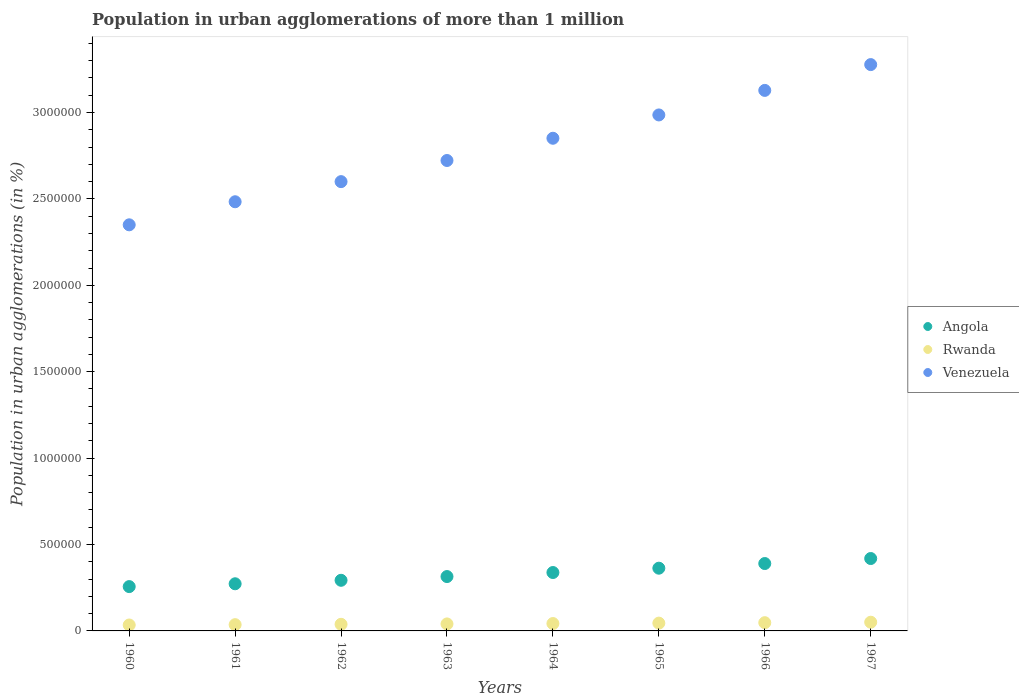What is the population in urban agglomerations in Rwanda in 1965?
Provide a short and direct response. 4.51e+04. Across all years, what is the maximum population in urban agglomerations in Venezuela?
Offer a terse response. 3.28e+06. Across all years, what is the minimum population in urban agglomerations in Angola?
Make the answer very short. 2.56e+05. In which year was the population in urban agglomerations in Rwanda maximum?
Your answer should be compact. 1967. In which year was the population in urban agglomerations in Angola minimum?
Your answer should be very brief. 1960. What is the total population in urban agglomerations in Venezuela in the graph?
Keep it short and to the point. 2.24e+07. What is the difference between the population in urban agglomerations in Angola in 1962 and that in 1964?
Your answer should be very brief. -4.50e+04. What is the difference between the population in urban agglomerations in Angola in 1967 and the population in urban agglomerations in Rwanda in 1964?
Your answer should be compact. 3.76e+05. What is the average population in urban agglomerations in Angola per year?
Provide a short and direct response. 3.31e+05. In the year 1966, what is the difference between the population in urban agglomerations in Angola and population in urban agglomerations in Venezuela?
Your answer should be compact. -2.74e+06. What is the ratio of the population in urban agglomerations in Angola in 1964 to that in 1965?
Ensure brevity in your answer.  0.93. What is the difference between the highest and the second highest population in urban agglomerations in Venezuela?
Give a very brief answer. 1.49e+05. What is the difference between the highest and the lowest population in urban agglomerations in Rwanda?
Offer a terse response. 1.61e+04. Is it the case that in every year, the sum of the population in urban agglomerations in Angola and population in urban agglomerations in Rwanda  is greater than the population in urban agglomerations in Venezuela?
Keep it short and to the point. No. Does the population in urban agglomerations in Rwanda monotonically increase over the years?
Provide a succinct answer. Yes. How many years are there in the graph?
Give a very brief answer. 8. Are the values on the major ticks of Y-axis written in scientific E-notation?
Keep it short and to the point. No. Does the graph contain grids?
Offer a terse response. No. How are the legend labels stacked?
Keep it short and to the point. Vertical. What is the title of the graph?
Offer a very short reply. Population in urban agglomerations of more than 1 million. Does "Fragile and conflict affected situations" appear as one of the legend labels in the graph?
Provide a short and direct response. No. What is the label or title of the Y-axis?
Your answer should be very brief. Population in urban agglomerations (in %). What is the Population in urban agglomerations (in %) in Angola in 1960?
Give a very brief answer. 2.56e+05. What is the Population in urban agglomerations (in %) of Rwanda in 1960?
Make the answer very short. 3.43e+04. What is the Population in urban agglomerations (in %) in Venezuela in 1960?
Ensure brevity in your answer.  2.35e+06. What is the Population in urban agglomerations (in %) in Angola in 1961?
Your response must be concise. 2.73e+05. What is the Population in urban agglomerations (in %) in Rwanda in 1961?
Your answer should be compact. 3.63e+04. What is the Population in urban agglomerations (in %) in Venezuela in 1961?
Your answer should be very brief. 2.48e+06. What is the Population in urban agglomerations (in %) in Angola in 1962?
Make the answer very short. 2.93e+05. What is the Population in urban agglomerations (in %) of Rwanda in 1962?
Keep it short and to the point. 3.83e+04. What is the Population in urban agglomerations (in %) of Venezuela in 1962?
Ensure brevity in your answer.  2.60e+06. What is the Population in urban agglomerations (in %) of Angola in 1963?
Your response must be concise. 3.15e+05. What is the Population in urban agglomerations (in %) of Rwanda in 1963?
Give a very brief answer. 4.05e+04. What is the Population in urban agglomerations (in %) of Venezuela in 1963?
Offer a very short reply. 2.72e+06. What is the Population in urban agglomerations (in %) in Angola in 1964?
Give a very brief answer. 3.38e+05. What is the Population in urban agglomerations (in %) in Rwanda in 1964?
Provide a succinct answer. 4.27e+04. What is the Population in urban agglomerations (in %) of Venezuela in 1964?
Your answer should be compact. 2.85e+06. What is the Population in urban agglomerations (in %) of Angola in 1965?
Offer a very short reply. 3.63e+05. What is the Population in urban agglomerations (in %) in Rwanda in 1965?
Ensure brevity in your answer.  4.51e+04. What is the Population in urban agglomerations (in %) of Venezuela in 1965?
Keep it short and to the point. 2.99e+06. What is the Population in urban agglomerations (in %) in Angola in 1966?
Keep it short and to the point. 3.90e+05. What is the Population in urban agglomerations (in %) in Rwanda in 1966?
Ensure brevity in your answer.  4.77e+04. What is the Population in urban agglomerations (in %) of Venezuela in 1966?
Make the answer very short. 3.13e+06. What is the Population in urban agglomerations (in %) of Angola in 1967?
Your answer should be compact. 4.19e+05. What is the Population in urban agglomerations (in %) of Rwanda in 1967?
Offer a terse response. 5.04e+04. What is the Population in urban agglomerations (in %) in Venezuela in 1967?
Make the answer very short. 3.28e+06. Across all years, what is the maximum Population in urban agglomerations (in %) of Angola?
Provide a succinct answer. 4.19e+05. Across all years, what is the maximum Population in urban agglomerations (in %) in Rwanda?
Give a very brief answer. 5.04e+04. Across all years, what is the maximum Population in urban agglomerations (in %) of Venezuela?
Your answer should be very brief. 3.28e+06. Across all years, what is the minimum Population in urban agglomerations (in %) of Angola?
Your answer should be very brief. 2.56e+05. Across all years, what is the minimum Population in urban agglomerations (in %) in Rwanda?
Your answer should be very brief. 3.43e+04. Across all years, what is the minimum Population in urban agglomerations (in %) of Venezuela?
Your answer should be compact. 2.35e+06. What is the total Population in urban agglomerations (in %) of Angola in the graph?
Give a very brief answer. 2.65e+06. What is the total Population in urban agglomerations (in %) of Rwanda in the graph?
Give a very brief answer. 3.35e+05. What is the total Population in urban agglomerations (in %) of Venezuela in the graph?
Offer a terse response. 2.24e+07. What is the difference between the Population in urban agglomerations (in %) of Angola in 1960 and that in 1961?
Make the answer very short. -1.63e+04. What is the difference between the Population in urban agglomerations (in %) of Rwanda in 1960 and that in 1961?
Make the answer very short. -1932. What is the difference between the Population in urban agglomerations (in %) of Venezuela in 1960 and that in 1961?
Ensure brevity in your answer.  -1.33e+05. What is the difference between the Population in urban agglomerations (in %) of Angola in 1960 and that in 1962?
Your answer should be compact. -3.65e+04. What is the difference between the Population in urban agglomerations (in %) of Rwanda in 1960 and that in 1962?
Offer a very short reply. -3976. What is the difference between the Population in urban agglomerations (in %) of Venezuela in 1960 and that in 1962?
Give a very brief answer. -2.50e+05. What is the difference between the Population in urban agglomerations (in %) of Angola in 1960 and that in 1963?
Offer a terse response. -5.81e+04. What is the difference between the Population in urban agglomerations (in %) in Rwanda in 1960 and that in 1963?
Offer a terse response. -6134. What is the difference between the Population in urban agglomerations (in %) in Venezuela in 1960 and that in 1963?
Give a very brief answer. -3.72e+05. What is the difference between the Population in urban agglomerations (in %) in Angola in 1960 and that in 1964?
Keep it short and to the point. -8.15e+04. What is the difference between the Population in urban agglomerations (in %) in Rwanda in 1960 and that in 1964?
Your response must be concise. -8418. What is the difference between the Population in urban agglomerations (in %) in Venezuela in 1960 and that in 1964?
Keep it short and to the point. -5.01e+05. What is the difference between the Population in urban agglomerations (in %) of Angola in 1960 and that in 1965?
Give a very brief answer. -1.06e+05. What is the difference between the Population in urban agglomerations (in %) of Rwanda in 1960 and that in 1965?
Make the answer very short. -1.08e+04. What is the difference between the Population in urban agglomerations (in %) of Venezuela in 1960 and that in 1965?
Your answer should be compact. -6.36e+05. What is the difference between the Population in urban agglomerations (in %) in Angola in 1960 and that in 1966?
Your answer should be compact. -1.33e+05. What is the difference between the Population in urban agglomerations (in %) in Rwanda in 1960 and that in 1966?
Make the answer very short. -1.34e+04. What is the difference between the Population in urban agglomerations (in %) in Venezuela in 1960 and that in 1966?
Your answer should be very brief. -7.78e+05. What is the difference between the Population in urban agglomerations (in %) in Angola in 1960 and that in 1967?
Give a very brief answer. -1.62e+05. What is the difference between the Population in urban agglomerations (in %) of Rwanda in 1960 and that in 1967?
Give a very brief answer. -1.61e+04. What is the difference between the Population in urban agglomerations (in %) of Venezuela in 1960 and that in 1967?
Your answer should be very brief. -9.27e+05. What is the difference between the Population in urban agglomerations (in %) of Angola in 1961 and that in 1962?
Keep it short and to the point. -2.02e+04. What is the difference between the Population in urban agglomerations (in %) of Rwanda in 1961 and that in 1962?
Your answer should be compact. -2044. What is the difference between the Population in urban agglomerations (in %) in Venezuela in 1961 and that in 1962?
Provide a succinct answer. -1.16e+05. What is the difference between the Population in urban agglomerations (in %) of Angola in 1961 and that in 1963?
Provide a succinct answer. -4.18e+04. What is the difference between the Population in urban agglomerations (in %) in Rwanda in 1961 and that in 1963?
Your answer should be very brief. -4202. What is the difference between the Population in urban agglomerations (in %) of Venezuela in 1961 and that in 1963?
Offer a terse response. -2.39e+05. What is the difference between the Population in urban agglomerations (in %) of Angola in 1961 and that in 1964?
Keep it short and to the point. -6.52e+04. What is the difference between the Population in urban agglomerations (in %) in Rwanda in 1961 and that in 1964?
Provide a succinct answer. -6486. What is the difference between the Population in urban agglomerations (in %) in Venezuela in 1961 and that in 1964?
Ensure brevity in your answer.  -3.67e+05. What is the difference between the Population in urban agglomerations (in %) of Angola in 1961 and that in 1965?
Ensure brevity in your answer.  -9.02e+04. What is the difference between the Population in urban agglomerations (in %) in Rwanda in 1961 and that in 1965?
Your answer should be very brief. -8892. What is the difference between the Population in urban agglomerations (in %) of Venezuela in 1961 and that in 1965?
Your answer should be very brief. -5.02e+05. What is the difference between the Population in urban agglomerations (in %) of Angola in 1961 and that in 1966?
Give a very brief answer. -1.17e+05. What is the difference between the Population in urban agglomerations (in %) in Rwanda in 1961 and that in 1966?
Provide a succinct answer. -1.14e+04. What is the difference between the Population in urban agglomerations (in %) of Venezuela in 1961 and that in 1966?
Offer a very short reply. -6.44e+05. What is the difference between the Population in urban agglomerations (in %) of Angola in 1961 and that in 1967?
Your response must be concise. -1.46e+05. What is the difference between the Population in urban agglomerations (in %) in Rwanda in 1961 and that in 1967?
Provide a short and direct response. -1.41e+04. What is the difference between the Population in urban agglomerations (in %) of Venezuela in 1961 and that in 1967?
Make the answer very short. -7.94e+05. What is the difference between the Population in urban agglomerations (in %) of Angola in 1962 and that in 1963?
Keep it short and to the point. -2.17e+04. What is the difference between the Population in urban agglomerations (in %) of Rwanda in 1962 and that in 1963?
Your answer should be compact. -2158. What is the difference between the Population in urban agglomerations (in %) in Venezuela in 1962 and that in 1963?
Keep it short and to the point. -1.22e+05. What is the difference between the Population in urban agglomerations (in %) in Angola in 1962 and that in 1964?
Offer a very short reply. -4.50e+04. What is the difference between the Population in urban agglomerations (in %) of Rwanda in 1962 and that in 1964?
Provide a succinct answer. -4442. What is the difference between the Population in urban agglomerations (in %) of Venezuela in 1962 and that in 1964?
Ensure brevity in your answer.  -2.51e+05. What is the difference between the Population in urban agglomerations (in %) of Angola in 1962 and that in 1965?
Keep it short and to the point. -7.00e+04. What is the difference between the Population in urban agglomerations (in %) of Rwanda in 1962 and that in 1965?
Offer a terse response. -6848. What is the difference between the Population in urban agglomerations (in %) in Venezuela in 1962 and that in 1965?
Offer a very short reply. -3.86e+05. What is the difference between the Population in urban agglomerations (in %) of Angola in 1962 and that in 1966?
Offer a very short reply. -9.70e+04. What is the difference between the Population in urban agglomerations (in %) of Rwanda in 1962 and that in 1966?
Give a very brief answer. -9393. What is the difference between the Population in urban agglomerations (in %) in Venezuela in 1962 and that in 1966?
Provide a succinct answer. -5.28e+05. What is the difference between the Population in urban agglomerations (in %) of Angola in 1962 and that in 1967?
Provide a short and direct response. -1.26e+05. What is the difference between the Population in urban agglomerations (in %) in Rwanda in 1962 and that in 1967?
Offer a terse response. -1.21e+04. What is the difference between the Population in urban agglomerations (in %) in Venezuela in 1962 and that in 1967?
Provide a succinct answer. -6.77e+05. What is the difference between the Population in urban agglomerations (in %) of Angola in 1963 and that in 1964?
Keep it short and to the point. -2.33e+04. What is the difference between the Population in urban agglomerations (in %) of Rwanda in 1963 and that in 1964?
Make the answer very short. -2284. What is the difference between the Population in urban agglomerations (in %) of Venezuela in 1963 and that in 1964?
Keep it short and to the point. -1.29e+05. What is the difference between the Population in urban agglomerations (in %) of Angola in 1963 and that in 1965?
Provide a short and direct response. -4.84e+04. What is the difference between the Population in urban agglomerations (in %) of Rwanda in 1963 and that in 1965?
Give a very brief answer. -4690. What is the difference between the Population in urban agglomerations (in %) of Venezuela in 1963 and that in 1965?
Ensure brevity in your answer.  -2.64e+05. What is the difference between the Population in urban agglomerations (in %) in Angola in 1963 and that in 1966?
Keep it short and to the point. -7.53e+04. What is the difference between the Population in urban agglomerations (in %) of Rwanda in 1963 and that in 1966?
Your response must be concise. -7235. What is the difference between the Population in urban agglomerations (in %) of Venezuela in 1963 and that in 1966?
Make the answer very short. -4.06e+05. What is the difference between the Population in urban agglomerations (in %) in Angola in 1963 and that in 1967?
Give a very brief answer. -1.04e+05. What is the difference between the Population in urban agglomerations (in %) of Rwanda in 1963 and that in 1967?
Your answer should be compact. -9924. What is the difference between the Population in urban agglomerations (in %) in Venezuela in 1963 and that in 1967?
Your answer should be very brief. -5.55e+05. What is the difference between the Population in urban agglomerations (in %) of Angola in 1964 and that in 1965?
Ensure brevity in your answer.  -2.50e+04. What is the difference between the Population in urban agglomerations (in %) of Rwanda in 1964 and that in 1965?
Provide a short and direct response. -2406. What is the difference between the Population in urban agglomerations (in %) of Venezuela in 1964 and that in 1965?
Your answer should be compact. -1.35e+05. What is the difference between the Population in urban agglomerations (in %) in Angola in 1964 and that in 1966?
Your answer should be very brief. -5.20e+04. What is the difference between the Population in urban agglomerations (in %) of Rwanda in 1964 and that in 1966?
Ensure brevity in your answer.  -4951. What is the difference between the Population in urban agglomerations (in %) in Venezuela in 1964 and that in 1966?
Your answer should be compact. -2.77e+05. What is the difference between the Population in urban agglomerations (in %) of Angola in 1964 and that in 1967?
Your answer should be compact. -8.10e+04. What is the difference between the Population in urban agglomerations (in %) of Rwanda in 1964 and that in 1967?
Ensure brevity in your answer.  -7640. What is the difference between the Population in urban agglomerations (in %) in Venezuela in 1964 and that in 1967?
Provide a succinct answer. -4.26e+05. What is the difference between the Population in urban agglomerations (in %) of Angola in 1965 and that in 1966?
Your response must be concise. -2.70e+04. What is the difference between the Population in urban agglomerations (in %) in Rwanda in 1965 and that in 1966?
Offer a very short reply. -2545. What is the difference between the Population in urban agglomerations (in %) in Venezuela in 1965 and that in 1966?
Make the answer very short. -1.42e+05. What is the difference between the Population in urban agglomerations (in %) of Angola in 1965 and that in 1967?
Make the answer very short. -5.60e+04. What is the difference between the Population in urban agglomerations (in %) of Rwanda in 1965 and that in 1967?
Make the answer very short. -5234. What is the difference between the Population in urban agglomerations (in %) of Venezuela in 1965 and that in 1967?
Your answer should be very brief. -2.91e+05. What is the difference between the Population in urban agglomerations (in %) in Angola in 1966 and that in 1967?
Give a very brief answer. -2.90e+04. What is the difference between the Population in urban agglomerations (in %) of Rwanda in 1966 and that in 1967?
Offer a very short reply. -2689. What is the difference between the Population in urban agglomerations (in %) in Venezuela in 1966 and that in 1967?
Ensure brevity in your answer.  -1.49e+05. What is the difference between the Population in urban agglomerations (in %) in Angola in 1960 and the Population in urban agglomerations (in %) in Rwanda in 1961?
Give a very brief answer. 2.20e+05. What is the difference between the Population in urban agglomerations (in %) in Angola in 1960 and the Population in urban agglomerations (in %) in Venezuela in 1961?
Provide a succinct answer. -2.23e+06. What is the difference between the Population in urban agglomerations (in %) in Rwanda in 1960 and the Population in urban agglomerations (in %) in Venezuela in 1961?
Your response must be concise. -2.45e+06. What is the difference between the Population in urban agglomerations (in %) of Angola in 1960 and the Population in urban agglomerations (in %) of Rwanda in 1962?
Offer a terse response. 2.18e+05. What is the difference between the Population in urban agglomerations (in %) of Angola in 1960 and the Population in urban agglomerations (in %) of Venezuela in 1962?
Your answer should be very brief. -2.34e+06. What is the difference between the Population in urban agglomerations (in %) of Rwanda in 1960 and the Population in urban agglomerations (in %) of Venezuela in 1962?
Your answer should be very brief. -2.57e+06. What is the difference between the Population in urban agglomerations (in %) of Angola in 1960 and the Population in urban agglomerations (in %) of Rwanda in 1963?
Make the answer very short. 2.16e+05. What is the difference between the Population in urban agglomerations (in %) of Angola in 1960 and the Population in urban agglomerations (in %) of Venezuela in 1963?
Give a very brief answer. -2.47e+06. What is the difference between the Population in urban agglomerations (in %) of Rwanda in 1960 and the Population in urban agglomerations (in %) of Venezuela in 1963?
Ensure brevity in your answer.  -2.69e+06. What is the difference between the Population in urban agglomerations (in %) of Angola in 1960 and the Population in urban agglomerations (in %) of Rwanda in 1964?
Ensure brevity in your answer.  2.14e+05. What is the difference between the Population in urban agglomerations (in %) of Angola in 1960 and the Population in urban agglomerations (in %) of Venezuela in 1964?
Your answer should be very brief. -2.59e+06. What is the difference between the Population in urban agglomerations (in %) in Rwanda in 1960 and the Population in urban agglomerations (in %) in Venezuela in 1964?
Make the answer very short. -2.82e+06. What is the difference between the Population in urban agglomerations (in %) of Angola in 1960 and the Population in urban agglomerations (in %) of Rwanda in 1965?
Your answer should be compact. 2.11e+05. What is the difference between the Population in urban agglomerations (in %) of Angola in 1960 and the Population in urban agglomerations (in %) of Venezuela in 1965?
Your answer should be compact. -2.73e+06. What is the difference between the Population in urban agglomerations (in %) of Rwanda in 1960 and the Population in urban agglomerations (in %) of Venezuela in 1965?
Offer a very short reply. -2.95e+06. What is the difference between the Population in urban agglomerations (in %) of Angola in 1960 and the Population in urban agglomerations (in %) of Rwanda in 1966?
Your response must be concise. 2.09e+05. What is the difference between the Population in urban agglomerations (in %) of Angola in 1960 and the Population in urban agglomerations (in %) of Venezuela in 1966?
Provide a short and direct response. -2.87e+06. What is the difference between the Population in urban agglomerations (in %) of Rwanda in 1960 and the Population in urban agglomerations (in %) of Venezuela in 1966?
Provide a succinct answer. -3.09e+06. What is the difference between the Population in urban agglomerations (in %) of Angola in 1960 and the Population in urban agglomerations (in %) of Rwanda in 1967?
Keep it short and to the point. 2.06e+05. What is the difference between the Population in urban agglomerations (in %) in Angola in 1960 and the Population in urban agglomerations (in %) in Venezuela in 1967?
Provide a short and direct response. -3.02e+06. What is the difference between the Population in urban agglomerations (in %) in Rwanda in 1960 and the Population in urban agglomerations (in %) in Venezuela in 1967?
Offer a very short reply. -3.24e+06. What is the difference between the Population in urban agglomerations (in %) in Angola in 1961 and the Population in urban agglomerations (in %) in Rwanda in 1962?
Offer a very short reply. 2.35e+05. What is the difference between the Population in urban agglomerations (in %) of Angola in 1961 and the Population in urban agglomerations (in %) of Venezuela in 1962?
Your answer should be compact. -2.33e+06. What is the difference between the Population in urban agglomerations (in %) of Rwanda in 1961 and the Population in urban agglomerations (in %) of Venezuela in 1962?
Provide a short and direct response. -2.56e+06. What is the difference between the Population in urban agglomerations (in %) of Angola in 1961 and the Population in urban agglomerations (in %) of Rwanda in 1963?
Your response must be concise. 2.32e+05. What is the difference between the Population in urban agglomerations (in %) in Angola in 1961 and the Population in urban agglomerations (in %) in Venezuela in 1963?
Your response must be concise. -2.45e+06. What is the difference between the Population in urban agglomerations (in %) of Rwanda in 1961 and the Population in urban agglomerations (in %) of Venezuela in 1963?
Provide a succinct answer. -2.69e+06. What is the difference between the Population in urban agglomerations (in %) in Angola in 1961 and the Population in urban agglomerations (in %) in Rwanda in 1964?
Provide a short and direct response. 2.30e+05. What is the difference between the Population in urban agglomerations (in %) of Angola in 1961 and the Population in urban agglomerations (in %) of Venezuela in 1964?
Offer a very short reply. -2.58e+06. What is the difference between the Population in urban agglomerations (in %) of Rwanda in 1961 and the Population in urban agglomerations (in %) of Venezuela in 1964?
Ensure brevity in your answer.  -2.81e+06. What is the difference between the Population in urban agglomerations (in %) of Angola in 1961 and the Population in urban agglomerations (in %) of Rwanda in 1965?
Give a very brief answer. 2.28e+05. What is the difference between the Population in urban agglomerations (in %) of Angola in 1961 and the Population in urban agglomerations (in %) of Venezuela in 1965?
Your answer should be compact. -2.71e+06. What is the difference between the Population in urban agglomerations (in %) of Rwanda in 1961 and the Population in urban agglomerations (in %) of Venezuela in 1965?
Make the answer very short. -2.95e+06. What is the difference between the Population in urban agglomerations (in %) in Angola in 1961 and the Population in urban agglomerations (in %) in Rwanda in 1966?
Give a very brief answer. 2.25e+05. What is the difference between the Population in urban agglomerations (in %) in Angola in 1961 and the Population in urban agglomerations (in %) in Venezuela in 1966?
Make the answer very short. -2.85e+06. What is the difference between the Population in urban agglomerations (in %) in Rwanda in 1961 and the Population in urban agglomerations (in %) in Venezuela in 1966?
Make the answer very short. -3.09e+06. What is the difference between the Population in urban agglomerations (in %) in Angola in 1961 and the Population in urban agglomerations (in %) in Rwanda in 1967?
Your response must be concise. 2.22e+05. What is the difference between the Population in urban agglomerations (in %) of Angola in 1961 and the Population in urban agglomerations (in %) of Venezuela in 1967?
Offer a terse response. -3.00e+06. What is the difference between the Population in urban agglomerations (in %) in Rwanda in 1961 and the Population in urban agglomerations (in %) in Venezuela in 1967?
Your answer should be very brief. -3.24e+06. What is the difference between the Population in urban agglomerations (in %) of Angola in 1962 and the Population in urban agglomerations (in %) of Rwanda in 1963?
Your response must be concise. 2.52e+05. What is the difference between the Population in urban agglomerations (in %) in Angola in 1962 and the Population in urban agglomerations (in %) in Venezuela in 1963?
Your response must be concise. -2.43e+06. What is the difference between the Population in urban agglomerations (in %) in Rwanda in 1962 and the Population in urban agglomerations (in %) in Venezuela in 1963?
Give a very brief answer. -2.68e+06. What is the difference between the Population in urban agglomerations (in %) in Angola in 1962 and the Population in urban agglomerations (in %) in Rwanda in 1964?
Ensure brevity in your answer.  2.50e+05. What is the difference between the Population in urban agglomerations (in %) in Angola in 1962 and the Population in urban agglomerations (in %) in Venezuela in 1964?
Offer a very short reply. -2.56e+06. What is the difference between the Population in urban agglomerations (in %) of Rwanda in 1962 and the Population in urban agglomerations (in %) of Venezuela in 1964?
Ensure brevity in your answer.  -2.81e+06. What is the difference between the Population in urban agglomerations (in %) in Angola in 1962 and the Population in urban agglomerations (in %) in Rwanda in 1965?
Your answer should be compact. 2.48e+05. What is the difference between the Population in urban agglomerations (in %) of Angola in 1962 and the Population in urban agglomerations (in %) of Venezuela in 1965?
Your response must be concise. -2.69e+06. What is the difference between the Population in urban agglomerations (in %) of Rwanda in 1962 and the Population in urban agglomerations (in %) of Venezuela in 1965?
Offer a very short reply. -2.95e+06. What is the difference between the Population in urban agglomerations (in %) in Angola in 1962 and the Population in urban agglomerations (in %) in Rwanda in 1966?
Keep it short and to the point. 2.45e+05. What is the difference between the Population in urban agglomerations (in %) in Angola in 1962 and the Population in urban agglomerations (in %) in Venezuela in 1966?
Offer a very short reply. -2.83e+06. What is the difference between the Population in urban agglomerations (in %) of Rwanda in 1962 and the Population in urban agglomerations (in %) of Venezuela in 1966?
Provide a succinct answer. -3.09e+06. What is the difference between the Population in urban agglomerations (in %) in Angola in 1962 and the Population in urban agglomerations (in %) in Rwanda in 1967?
Your answer should be very brief. 2.43e+05. What is the difference between the Population in urban agglomerations (in %) of Angola in 1962 and the Population in urban agglomerations (in %) of Venezuela in 1967?
Provide a succinct answer. -2.98e+06. What is the difference between the Population in urban agglomerations (in %) in Rwanda in 1962 and the Population in urban agglomerations (in %) in Venezuela in 1967?
Offer a very short reply. -3.24e+06. What is the difference between the Population in urban agglomerations (in %) in Angola in 1963 and the Population in urban agglomerations (in %) in Rwanda in 1964?
Make the answer very short. 2.72e+05. What is the difference between the Population in urban agglomerations (in %) in Angola in 1963 and the Population in urban agglomerations (in %) in Venezuela in 1964?
Your response must be concise. -2.54e+06. What is the difference between the Population in urban agglomerations (in %) of Rwanda in 1963 and the Population in urban agglomerations (in %) of Venezuela in 1964?
Give a very brief answer. -2.81e+06. What is the difference between the Population in urban agglomerations (in %) in Angola in 1963 and the Population in urban agglomerations (in %) in Rwanda in 1965?
Your answer should be compact. 2.69e+05. What is the difference between the Population in urban agglomerations (in %) in Angola in 1963 and the Population in urban agglomerations (in %) in Venezuela in 1965?
Make the answer very short. -2.67e+06. What is the difference between the Population in urban agglomerations (in %) in Rwanda in 1963 and the Population in urban agglomerations (in %) in Venezuela in 1965?
Offer a very short reply. -2.95e+06. What is the difference between the Population in urban agglomerations (in %) in Angola in 1963 and the Population in urban agglomerations (in %) in Rwanda in 1966?
Ensure brevity in your answer.  2.67e+05. What is the difference between the Population in urban agglomerations (in %) of Angola in 1963 and the Population in urban agglomerations (in %) of Venezuela in 1966?
Offer a very short reply. -2.81e+06. What is the difference between the Population in urban agglomerations (in %) of Rwanda in 1963 and the Population in urban agglomerations (in %) of Venezuela in 1966?
Your response must be concise. -3.09e+06. What is the difference between the Population in urban agglomerations (in %) in Angola in 1963 and the Population in urban agglomerations (in %) in Rwanda in 1967?
Keep it short and to the point. 2.64e+05. What is the difference between the Population in urban agglomerations (in %) of Angola in 1963 and the Population in urban agglomerations (in %) of Venezuela in 1967?
Make the answer very short. -2.96e+06. What is the difference between the Population in urban agglomerations (in %) in Rwanda in 1963 and the Population in urban agglomerations (in %) in Venezuela in 1967?
Give a very brief answer. -3.24e+06. What is the difference between the Population in urban agglomerations (in %) of Angola in 1964 and the Population in urban agglomerations (in %) of Rwanda in 1965?
Your response must be concise. 2.93e+05. What is the difference between the Population in urban agglomerations (in %) in Angola in 1964 and the Population in urban agglomerations (in %) in Venezuela in 1965?
Provide a succinct answer. -2.65e+06. What is the difference between the Population in urban agglomerations (in %) in Rwanda in 1964 and the Population in urban agglomerations (in %) in Venezuela in 1965?
Your response must be concise. -2.94e+06. What is the difference between the Population in urban agglomerations (in %) of Angola in 1964 and the Population in urban agglomerations (in %) of Rwanda in 1966?
Offer a very short reply. 2.90e+05. What is the difference between the Population in urban agglomerations (in %) in Angola in 1964 and the Population in urban agglomerations (in %) in Venezuela in 1966?
Provide a succinct answer. -2.79e+06. What is the difference between the Population in urban agglomerations (in %) of Rwanda in 1964 and the Population in urban agglomerations (in %) of Venezuela in 1966?
Keep it short and to the point. -3.09e+06. What is the difference between the Population in urban agglomerations (in %) in Angola in 1964 and the Population in urban agglomerations (in %) in Rwanda in 1967?
Ensure brevity in your answer.  2.88e+05. What is the difference between the Population in urban agglomerations (in %) of Angola in 1964 and the Population in urban agglomerations (in %) of Venezuela in 1967?
Offer a terse response. -2.94e+06. What is the difference between the Population in urban agglomerations (in %) in Rwanda in 1964 and the Population in urban agglomerations (in %) in Venezuela in 1967?
Provide a succinct answer. -3.23e+06. What is the difference between the Population in urban agglomerations (in %) of Angola in 1965 and the Population in urban agglomerations (in %) of Rwanda in 1966?
Your answer should be compact. 3.15e+05. What is the difference between the Population in urban agglomerations (in %) in Angola in 1965 and the Population in urban agglomerations (in %) in Venezuela in 1966?
Your answer should be compact. -2.76e+06. What is the difference between the Population in urban agglomerations (in %) of Rwanda in 1965 and the Population in urban agglomerations (in %) of Venezuela in 1966?
Your response must be concise. -3.08e+06. What is the difference between the Population in urban agglomerations (in %) of Angola in 1965 and the Population in urban agglomerations (in %) of Rwanda in 1967?
Give a very brief answer. 3.13e+05. What is the difference between the Population in urban agglomerations (in %) of Angola in 1965 and the Population in urban agglomerations (in %) of Venezuela in 1967?
Ensure brevity in your answer.  -2.91e+06. What is the difference between the Population in urban agglomerations (in %) in Rwanda in 1965 and the Population in urban agglomerations (in %) in Venezuela in 1967?
Ensure brevity in your answer.  -3.23e+06. What is the difference between the Population in urban agglomerations (in %) in Angola in 1966 and the Population in urban agglomerations (in %) in Rwanda in 1967?
Your answer should be compact. 3.40e+05. What is the difference between the Population in urban agglomerations (in %) in Angola in 1966 and the Population in urban agglomerations (in %) in Venezuela in 1967?
Offer a very short reply. -2.89e+06. What is the difference between the Population in urban agglomerations (in %) of Rwanda in 1966 and the Population in urban agglomerations (in %) of Venezuela in 1967?
Offer a terse response. -3.23e+06. What is the average Population in urban agglomerations (in %) in Angola per year?
Provide a succinct answer. 3.31e+05. What is the average Population in urban agglomerations (in %) in Rwanda per year?
Your answer should be compact. 4.19e+04. What is the average Population in urban agglomerations (in %) of Venezuela per year?
Ensure brevity in your answer.  2.80e+06. In the year 1960, what is the difference between the Population in urban agglomerations (in %) in Angola and Population in urban agglomerations (in %) in Rwanda?
Provide a succinct answer. 2.22e+05. In the year 1960, what is the difference between the Population in urban agglomerations (in %) of Angola and Population in urban agglomerations (in %) of Venezuela?
Ensure brevity in your answer.  -2.09e+06. In the year 1960, what is the difference between the Population in urban agglomerations (in %) of Rwanda and Population in urban agglomerations (in %) of Venezuela?
Give a very brief answer. -2.32e+06. In the year 1961, what is the difference between the Population in urban agglomerations (in %) of Angola and Population in urban agglomerations (in %) of Rwanda?
Your response must be concise. 2.37e+05. In the year 1961, what is the difference between the Population in urban agglomerations (in %) in Angola and Population in urban agglomerations (in %) in Venezuela?
Your answer should be very brief. -2.21e+06. In the year 1961, what is the difference between the Population in urban agglomerations (in %) in Rwanda and Population in urban agglomerations (in %) in Venezuela?
Ensure brevity in your answer.  -2.45e+06. In the year 1962, what is the difference between the Population in urban agglomerations (in %) in Angola and Population in urban agglomerations (in %) in Rwanda?
Keep it short and to the point. 2.55e+05. In the year 1962, what is the difference between the Population in urban agglomerations (in %) in Angola and Population in urban agglomerations (in %) in Venezuela?
Give a very brief answer. -2.31e+06. In the year 1962, what is the difference between the Population in urban agglomerations (in %) of Rwanda and Population in urban agglomerations (in %) of Venezuela?
Give a very brief answer. -2.56e+06. In the year 1963, what is the difference between the Population in urban agglomerations (in %) in Angola and Population in urban agglomerations (in %) in Rwanda?
Give a very brief answer. 2.74e+05. In the year 1963, what is the difference between the Population in urban agglomerations (in %) in Angola and Population in urban agglomerations (in %) in Venezuela?
Offer a very short reply. -2.41e+06. In the year 1963, what is the difference between the Population in urban agglomerations (in %) in Rwanda and Population in urban agglomerations (in %) in Venezuela?
Ensure brevity in your answer.  -2.68e+06. In the year 1964, what is the difference between the Population in urban agglomerations (in %) in Angola and Population in urban agglomerations (in %) in Rwanda?
Offer a terse response. 2.95e+05. In the year 1964, what is the difference between the Population in urban agglomerations (in %) of Angola and Population in urban agglomerations (in %) of Venezuela?
Ensure brevity in your answer.  -2.51e+06. In the year 1964, what is the difference between the Population in urban agglomerations (in %) in Rwanda and Population in urban agglomerations (in %) in Venezuela?
Make the answer very short. -2.81e+06. In the year 1965, what is the difference between the Population in urban agglomerations (in %) in Angola and Population in urban agglomerations (in %) in Rwanda?
Make the answer very short. 3.18e+05. In the year 1965, what is the difference between the Population in urban agglomerations (in %) in Angola and Population in urban agglomerations (in %) in Venezuela?
Provide a succinct answer. -2.62e+06. In the year 1965, what is the difference between the Population in urban agglomerations (in %) in Rwanda and Population in urban agglomerations (in %) in Venezuela?
Make the answer very short. -2.94e+06. In the year 1966, what is the difference between the Population in urban agglomerations (in %) in Angola and Population in urban agglomerations (in %) in Rwanda?
Make the answer very short. 3.42e+05. In the year 1966, what is the difference between the Population in urban agglomerations (in %) in Angola and Population in urban agglomerations (in %) in Venezuela?
Your answer should be very brief. -2.74e+06. In the year 1966, what is the difference between the Population in urban agglomerations (in %) of Rwanda and Population in urban agglomerations (in %) of Venezuela?
Provide a short and direct response. -3.08e+06. In the year 1967, what is the difference between the Population in urban agglomerations (in %) of Angola and Population in urban agglomerations (in %) of Rwanda?
Keep it short and to the point. 3.69e+05. In the year 1967, what is the difference between the Population in urban agglomerations (in %) in Angola and Population in urban agglomerations (in %) in Venezuela?
Make the answer very short. -2.86e+06. In the year 1967, what is the difference between the Population in urban agglomerations (in %) in Rwanda and Population in urban agglomerations (in %) in Venezuela?
Your answer should be very brief. -3.23e+06. What is the ratio of the Population in urban agglomerations (in %) in Angola in 1960 to that in 1961?
Offer a terse response. 0.94. What is the ratio of the Population in urban agglomerations (in %) in Rwanda in 1960 to that in 1961?
Ensure brevity in your answer.  0.95. What is the ratio of the Population in urban agglomerations (in %) of Venezuela in 1960 to that in 1961?
Provide a short and direct response. 0.95. What is the ratio of the Population in urban agglomerations (in %) of Angola in 1960 to that in 1962?
Ensure brevity in your answer.  0.88. What is the ratio of the Population in urban agglomerations (in %) of Rwanda in 1960 to that in 1962?
Your answer should be compact. 0.9. What is the ratio of the Population in urban agglomerations (in %) in Venezuela in 1960 to that in 1962?
Ensure brevity in your answer.  0.9. What is the ratio of the Population in urban agglomerations (in %) in Angola in 1960 to that in 1963?
Your response must be concise. 0.82. What is the ratio of the Population in urban agglomerations (in %) of Rwanda in 1960 to that in 1963?
Offer a terse response. 0.85. What is the ratio of the Population in urban agglomerations (in %) in Venezuela in 1960 to that in 1963?
Ensure brevity in your answer.  0.86. What is the ratio of the Population in urban agglomerations (in %) in Angola in 1960 to that in 1964?
Give a very brief answer. 0.76. What is the ratio of the Population in urban agglomerations (in %) of Rwanda in 1960 to that in 1964?
Offer a very short reply. 0.8. What is the ratio of the Population in urban agglomerations (in %) of Venezuela in 1960 to that in 1964?
Provide a short and direct response. 0.82. What is the ratio of the Population in urban agglomerations (in %) in Angola in 1960 to that in 1965?
Your answer should be very brief. 0.71. What is the ratio of the Population in urban agglomerations (in %) in Rwanda in 1960 to that in 1965?
Give a very brief answer. 0.76. What is the ratio of the Population in urban agglomerations (in %) of Venezuela in 1960 to that in 1965?
Offer a very short reply. 0.79. What is the ratio of the Population in urban agglomerations (in %) in Angola in 1960 to that in 1966?
Your answer should be compact. 0.66. What is the ratio of the Population in urban agglomerations (in %) of Rwanda in 1960 to that in 1966?
Your response must be concise. 0.72. What is the ratio of the Population in urban agglomerations (in %) of Venezuela in 1960 to that in 1966?
Give a very brief answer. 0.75. What is the ratio of the Population in urban agglomerations (in %) of Angola in 1960 to that in 1967?
Your answer should be very brief. 0.61. What is the ratio of the Population in urban agglomerations (in %) in Rwanda in 1960 to that in 1967?
Make the answer very short. 0.68. What is the ratio of the Population in urban agglomerations (in %) of Venezuela in 1960 to that in 1967?
Ensure brevity in your answer.  0.72. What is the ratio of the Population in urban agglomerations (in %) of Angola in 1961 to that in 1962?
Provide a short and direct response. 0.93. What is the ratio of the Population in urban agglomerations (in %) in Rwanda in 1961 to that in 1962?
Your answer should be compact. 0.95. What is the ratio of the Population in urban agglomerations (in %) in Venezuela in 1961 to that in 1962?
Your answer should be very brief. 0.96. What is the ratio of the Population in urban agglomerations (in %) in Angola in 1961 to that in 1963?
Provide a short and direct response. 0.87. What is the ratio of the Population in urban agglomerations (in %) in Rwanda in 1961 to that in 1963?
Make the answer very short. 0.9. What is the ratio of the Population in urban agglomerations (in %) in Venezuela in 1961 to that in 1963?
Your answer should be compact. 0.91. What is the ratio of the Population in urban agglomerations (in %) in Angola in 1961 to that in 1964?
Give a very brief answer. 0.81. What is the ratio of the Population in urban agglomerations (in %) of Rwanda in 1961 to that in 1964?
Keep it short and to the point. 0.85. What is the ratio of the Population in urban agglomerations (in %) in Venezuela in 1961 to that in 1964?
Your response must be concise. 0.87. What is the ratio of the Population in urban agglomerations (in %) in Angola in 1961 to that in 1965?
Keep it short and to the point. 0.75. What is the ratio of the Population in urban agglomerations (in %) in Rwanda in 1961 to that in 1965?
Give a very brief answer. 0.8. What is the ratio of the Population in urban agglomerations (in %) in Venezuela in 1961 to that in 1965?
Give a very brief answer. 0.83. What is the ratio of the Population in urban agglomerations (in %) of Angola in 1961 to that in 1966?
Provide a short and direct response. 0.7. What is the ratio of the Population in urban agglomerations (in %) of Rwanda in 1961 to that in 1966?
Give a very brief answer. 0.76. What is the ratio of the Population in urban agglomerations (in %) in Venezuela in 1961 to that in 1966?
Your response must be concise. 0.79. What is the ratio of the Population in urban agglomerations (in %) of Angola in 1961 to that in 1967?
Offer a very short reply. 0.65. What is the ratio of the Population in urban agglomerations (in %) of Rwanda in 1961 to that in 1967?
Offer a very short reply. 0.72. What is the ratio of the Population in urban agglomerations (in %) in Venezuela in 1961 to that in 1967?
Your answer should be compact. 0.76. What is the ratio of the Population in urban agglomerations (in %) of Angola in 1962 to that in 1963?
Make the answer very short. 0.93. What is the ratio of the Population in urban agglomerations (in %) in Rwanda in 1962 to that in 1963?
Give a very brief answer. 0.95. What is the ratio of the Population in urban agglomerations (in %) in Venezuela in 1962 to that in 1963?
Offer a terse response. 0.96. What is the ratio of the Population in urban agglomerations (in %) in Angola in 1962 to that in 1964?
Offer a very short reply. 0.87. What is the ratio of the Population in urban agglomerations (in %) in Rwanda in 1962 to that in 1964?
Ensure brevity in your answer.  0.9. What is the ratio of the Population in urban agglomerations (in %) in Venezuela in 1962 to that in 1964?
Make the answer very short. 0.91. What is the ratio of the Population in urban agglomerations (in %) in Angola in 1962 to that in 1965?
Provide a succinct answer. 0.81. What is the ratio of the Population in urban agglomerations (in %) of Rwanda in 1962 to that in 1965?
Your answer should be compact. 0.85. What is the ratio of the Population in urban agglomerations (in %) in Venezuela in 1962 to that in 1965?
Your answer should be very brief. 0.87. What is the ratio of the Population in urban agglomerations (in %) in Angola in 1962 to that in 1966?
Keep it short and to the point. 0.75. What is the ratio of the Population in urban agglomerations (in %) of Rwanda in 1962 to that in 1966?
Offer a terse response. 0.8. What is the ratio of the Population in urban agglomerations (in %) in Venezuela in 1962 to that in 1966?
Provide a short and direct response. 0.83. What is the ratio of the Population in urban agglomerations (in %) in Angola in 1962 to that in 1967?
Provide a succinct answer. 0.7. What is the ratio of the Population in urban agglomerations (in %) of Rwanda in 1962 to that in 1967?
Ensure brevity in your answer.  0.76. What is the ratio of the Population in urban agglomerations (in %) of Venezuela in 1962 to that in 1967?
Offer a terse response. 0.79. What is the ratio of the Population in urban agglomerations (in %) in Angola in 1963 to that in 1964?
Ensure brevity in your answer.  0.93. What is the ratio of the Population in urban agglomerations (in %) in Rwanda in 1963 to that in 1964?
Provide a short and direct response. 0.95. What is the ratio of the Population in urban agglomerations (in %) of Venezuela in 1963 to that in 1964?
Give a very brief answer. 0.95. What is the ratio of the Population in urban agglomerations (in %) in Angola in 1963 to that in 1965?
Offer a terse response. 0.87. What is the ratio of the Population in urban agglomerations (in %) of Rwanda in 1963 to that in 1965?
Offer a terse response. 0.9. What is the ratio of the Population in urban agglomerations (in %) in Venezuela in 1963 to that in 1965?
Ensure brevity in your answer.  0.91. What is the ratio of the Population in urban agglomerations (in %) in Angola in 1963 to that in 1966?
Provide a short and direct response. 0.81. What is the ratio of the Population in urban agglomerations (in %) of Rwanda in 1963 to that in 1966?
Offer a very short reply. 0.85. What is the ratio of the Population in urban agglomerations (in %) in Venezuela in 1963 to that in 1966?
Make the answer very short. 0.87. What is the ratio of the Population in urban agglomerations (in %) in Angola in 1963 to that in 1967?
Your answer should be compact. 0.75. What is the ratio of the Population in urban agglomerations (in %) of Rwanda in 1963 to that in 1967?
Your response must be concise. 0.8. What is the ratio of the Population in urban agglomerations (in %) in Venezuela in 1963 to that in 1967?
Your response must be concise. 0.83. What is the ratio of the Population in urban agglomerations (in %) of Angola in 1964 to that in 1965?
Provide a short and direct response. 0.93. What is the ratio of the Population in urban agglomerations (in %) in Rwanda in 1964 to that in 1965?
Make the answer very short. 0.95. What is the ratio of the Population in urban agglomerations (in %) in Venezuela in 1964 to that in 1965?
Offer a terse response. 0.95. What is the ratio of the Population in urban agglomerations (in %) in Angola in 1964 to that in 1966?
Keep it short and to the point. 0.87. What is the ratio of the Population in urban agglomerations (in %) in Rwanda in 1964 to that in 1966?
Keep it short and to the point. 0.9. What is the ratio of the Population in urban agglomerations (in %) in Venezuela in 1964 to that in 1966?
Offer a very short reply. 0.91. What is the ratio of the Population in urban agglomerations (in %) in Angola in 1964 to that in 1967?
Make the answer very short. 0.81. What is the ratio of the Population in urban agglomerations (in %) in Rwanda in 1964 to that in 1967?
Keep it short and to the point. 0.85. What is the ratio of the Population in urban agglomerations (in %) of Venezuela in 1964 to that in 1967?
Make the answer very short. 0.87. What is the ratio of the Population in urban agglomerations (in %) of Angola in 1965 to that in 1966?
Give a very brief answer. 0.93. What is the ratio of the Population in urban agglomerations (in %) of Rwanda in 1965 to that in 1966?
Your answer should be compact. 0.95. What is the ratio of the Population in urban agglomerations (in %) of Venezuela in 1965 to that in 1966?
Provide a short and direct response. 0.95. What is the ratio of the Population in urban agglomerations (in %) in Angola in 1965 to that in 1967?
Give a very brief answer. 0.87. What is the ratio of the Population in urban agglomerations (in %) in Rwanda in 1965 to that in 1967?
Provide a short and direct response. 0.9. What is the ratio of the Population in urban agglomerations (in %) in Venezuela in 1965 to that in 1967?
Make the answer very short. 0.91. What is the ratio of the Population in urban agglomerations (in %) of Angola in 1966 to that in 1967?
Offer a terse response. 0.93. What is the ratio of the Population in urban agglomerations (in %) in Rwanda in 1966 to that in 1967?
Make the answer very short. 0.95. What is the ratio of the Population in urban agglomerations (in %) in Venezuela in 1966 to that in 1967?
Make the answer very short. 0.95. What is the difference between the highest and the second highest Population in urban agglomerations (in %) in Angola?
Offer a terse response. 2.90e+04. What is the difference between the highest and the second highest Population in urban agglomerations (in %) in Rwanda?
Your answer should be very brief. 2689. What is the difference between the highest and the second highest Population in urban agglomerations (in %) of Venezuela?
Your response must be concise. 1.49e+05. What is the difference between the highest and the lowest Population in urban agglomerations (in %) of Angola?
Make the answer very short. 1.62e+05. What is the difference between the highest and the lowest Population in urban agglomerations (in %) of Rwanda?
Your answer should be compact. 1.61e+04. What is the difference between the highest and the lowest Population in urban agglomerations (in %) of Venezuela?
Your response must be concise. 9.27e+05. 